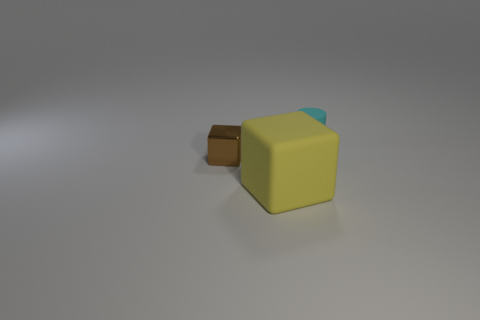What colors are present on the larger object in the image, and what does its shape resemble? The larger object in the image displays yellow as its primary color, with hints of blue on one of its faces. Its shape somewhat resembles a cube with a slightly extended portion on one side. 